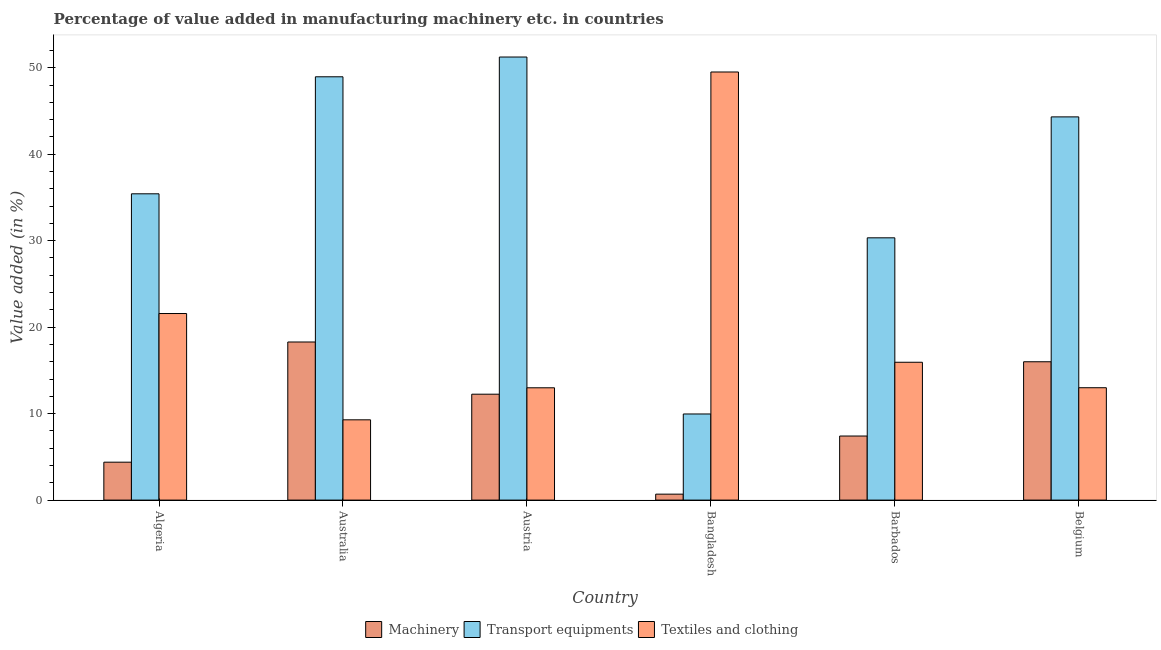Are the number of bars on each tick of the X-axis equal?
Ensure brevity in your answer.  Yes. How many bars are there on the 4th tick from the right?
Give a very brief answer. 3. In how many cases, is the number of bars for a given country not equal to the number of legend labels?
Your response must be concise. 0. What is the value added in manufacturing machinery in Belgium?
Ensure brevity in your answer.  16. Across all countries, what is the maximum value added in manufacturing textile and clothing?
Offer a terse response. 49.51. Across all countries, what is the minimum value added in manufacturing machinery?
Provide a succinct answer. 0.69. In which country was the value added in manufacturing textile and clothing minimum?
Keep it short and to the point. Australia. What is the total value added in manufacturing machinery in the graph?
Your response must be concise. 59.01. What is the difference between the value added in manufacturing transport equipments in Algeria and that in Barbados?
Give a very brief answer. 5.09. What is the difference between the value added in manufacturing textile and clothing in Belgium and the value added in manufacturing transport equipments in Austria?
Make the answer very short. -38.24. What is the average value added in manufacturing machinery per country?
Offer a terse response. 9.83. What is the difference between the value added in manufacturing textile and clothing and value added in manufacturing machinery in Algeria?
Offer a terse response. 17.19. What is the ratio of the value added in manufacturing transport equipments in Australia to that in Belgium?
Offer a very short reply. 1.1. What is the difference between the highest and the second highest value added in manufacturing transport equipments?
Ensure brevity in your answer.  2.28. What is the difference between the highest and the lowest value added in manufacturing machinery?
Offer a very short reply. 17.59. In how many countries, is the value added in manufacturing transport equipments greater than the average value added in manufacturing transport equipments taken over all countries?
Offer a very short reply. 3. What does the 1st bar from the left in Australia represents?
Your response must be concise. Machinery. What does the 1st bar from the right in Algeria represents?
Your answer should be compact. Textiles and clothing. How many bars are there?
Your answer should be very brief. 18. What is the difference between two consecutive major ticks on the Y-axis?
Offer a terse response. 10. Does the graph contain grids?
Offer a terse response. No. How many legend labels are there?
Offer a terse response. 3. How are the legend labels stacked?
Make the answer very short. Horizontal. What is the title of the graph?
Give a very brief answer. Percentage of value added in manufacturing machinery etc. in countries. Does "Central government" appear as one of the legend labels in the graph?
Keep it short and to the point. No. What is the label or title of the Y-axis?
Make the answer very short. Value added (in %). What is the Value added (in %) of Machinery in Algeria?
Your answer should be compact. 4.38. What is the Value added (in %) of Transport equipments in Algeria?
Make the answer very short. 35.42. What is the Value added (in %) in Textiles and clothing in Algeria?
Your answer should be compact. 21.57. What is the Value added (in %) of Machinery in Australia?
Your response must be concise. 18.28. What is the Value added (in %) in Transport equipments in Australia?
Make the answer very short. 48.95. What is the Value added (in %) in Textiles and clothing in Australia?
Your answer should be very brief. 9.28. What is the Value added (in %) in Machinery in Austria?
Offer a very short reply. 12.25. What is the Value added (in %) of Transport equipments in Austria?
Provide a short and direct response. 51.24. What is the Value added (in %) of Textiles and clothing in Austria?
Provide a succinct answer. 12.99. What is the Value added (in %) of Machinery in Bangladesh?
Offer a very short reply. 0.69. What is the Value added (in %) in Transport equipments in Bangladesh?
Offer a very short reply. 9.96. What is the Value added (in %) in Textiles and clothing in Bangladesh?
Give a very brief answer. 49.51. What is the Value added (in %) in Machinery in Barbados?
Give a very brief answer. 7.41. What is the Value added (in %) of Transport equipments in Barbados?
Your answer should be very brief. 30.33. What is the Value added (in %) in Textiles and clothing in Barbados?
Offer a terse response. 15.94. What is the Value added (in %) in Machinery in Belgium?
Your response must be concise. 16. What is the Value added (in %) in Transport equipments in Belgium?
Offer a terse response. 44.31. What is the Value added (in %) in Textiles and clothing in Belgium?
Your answer should be very brief. 12.99. Across all countries, what is the maximum Value added (in %) in Machinery?
Ensure brevity in your answer.  18.28. Across all countries, what is the maximum Value added (in %) of Transport equipments?
Keep it short and to the point. 51.24. Across all countries, what is the maximum Value added (in %) in Textiles and clothing?
Keep it short and to the point. 49.51. Across all countries, what is the minimum Value added (in %) in Machinery?
Provide a short and direct response. 0.69. Across all countries, what is the minimum Value added (in %) of Transport equipments?
Give a very brief answer. 9.96. Across all countries, what is the minimum Value added (in %) of Textiles and clothing?
Provide a succinct answer. 9.28. What is the total Value added (in %) of Machinery in the graph?
Provide a short and direct response. 59.01. What is the total Value added (in %) of Transport equipments in the graph?
Ensure brevity in your answer.  220.21. What is the total Value added (in %) in Textiles and clothing in the graph?
Your response must be concise. 122.28. What is the difference between the Value added (in %) in Machinery in Algeria and that in Australia?
Keep it short and to the point. -13.9. What is the difference between the Value added (in %) in Transport equipments in Algeria and that in Australia?
Your answer should be very brief. -13.53. What is the difference between the Value added (in %) of Textiles and clothing in Algeria and that in Australia?
Provide a short and direct response. 12.29. What is the difference between the Value added (in %) of Machinery in Algeria and that in Austria?
Offer a terse response. -7.86. What is the difference between the Value added (in %) in Transport equipments in Algeria and that in Austria?
Your answer should be compact. -15.82. What is the difference between the Value added (in %) of Textiles and clothing in Algeria and that in Austria?
Keep it short and to the point. 8.59. What is the difference between the Value added (in %) in Machinery in Algeria and that in Bangladesh?
Ensure brevity in your answer.  3.7. What is the difference between the Value added (in %) in Transport equipments in Algeria and that in Bangladesh?
Offer a very short reply. 25.46. What is the difference between the Value added (in %) of Textiles and clothing in Algeria and that in Bangladesh?
Make the answer very short. -27.93. What is the difference between the Value added (in %) of Machinery in Algeria and that in Barbados?
Your answer should be very brief. -3.03. What is the difference between the Value added (in %) of Transport equipments in Algeria and that in Barbados?
Provide a succinct answer. 5.09. What is the difference between the Value added (in %) of Textiles and clothing in Algeria and that in Barbados?
Give a very brief answer. 5.63. What is the difference between the Value added (in %) of Machinery in Algeria and that in Belgium?
Offer a very short reply. -11.61. What is the difference between the Value added (in %) in Transport equipments in Algeria and that in Belgium?
Your answer should be compact. -8.89. What is the difference between the Value added (in %) in Textiles and clothing in Algeria and that in Belgium?
Offer a terse response. 8.58. What is the difference between the Value added (in %) of Machinery in Australia and that in Austria?
Provide a short and direct response. 6.04. What is the difference between the Value added (in %) in Transport equipments in Australia and that in Austria?
Your answer should be very brief. -2.28. What is the difference between the Value added (in %) in Textiles and clothing in Australia and that in Austria?
Your answer should be very brief. -3.7. What is the difference between the Value added (in %) in Machinery in Australia and that in Bangladesh?
Offer a terse response. 17.59. What is the difference between the Value added (in %) in Transport equipments in Australia and that in Bangladesh?
Offer a terse response. 38.99. What is the difference between the Value added (in %) in Textiles and clothing in Australia and that in Bangladesh?
Keep it short and to the point. -40.22. What is the difference between the Value added (in %) of Machinery in Australia and that in Barbados?
Ensure brevity in your answer.  10.87. What is the difference between the Value added (in %) of Transport equipments in Australia and that in Barbados?
Offer a terse response. 18.62. What is the difference between the Value added (in %) of Textiles and clothing in Australia and that in Barbados?
Offer a terse response. -6.66. What is the difference between the Value added (in %) of Machinery in Australia and that in Belgium?
Your answer should be compact. 2.29. What is the difference between the Value added (in %) in Transport equipments in Australia and that in Belgium?
Provide a short and direct response. 4.64. What is the difference between the Value added (in %) in Textiles and clothing in Australia and that in Belgium?
Provide a succinct answer. -3.71. What is the difference between the Value added (in %) in Machinery in Austria and that in Bangladesh?
Your answer should be compact. 11.56. What is the difference between the Value added (in %) in Transport equipments in Austria and that in Bangladesh?
Keep it short and to the point. 41.28. What is the difference between the Value added (in %) of Textiles and clothing in Austria and that in Bangladesh?
Your response must be concise. -36.52. What is the difference between the Value added (in %) in Machinery in Austria and that in Barbados?
Offer a terse response. 4.84. What is the difference between the Value added (in %) of Transport equipments in Austria and that in Barbados?
Ensure brevity in your answer.  20.91. What is the difference between the Value added (in %) in Textiles and clothing in Austria and that in Barbados?
Your answer should be compact. -2.95. What is the difference between the Value added (in %) in Machinery in Austria and that in Belgium?
Your response must be concise. -3.75. What is the difference between the Value added (in %) in Transport equipments in Austria and that in Belgium?
Give a very brief answer. 6.92. What is the difference between the Value added (in %) of Textiles and clothing in Austria and that in Belgium?
Give a very brief answer. -0.01. What is the difference between the Value added (in %) in Machinery in Bangladesh and that in Barbados?
Your response must be concise. -6.72. What is the difference between the Value added (in %) of Transport equipments in Bangladesh and that in Barbados?
Your answer should be very brief. -20.37. What is the difference between the Value added (in %) of Textiles and clothing in Bangladesh and that in Barbados?
Your answer should be compact. 33.57. What is the difference between the Value added (in %) in Machinery in Bangladesh and that in Belgium?
Your answer should be very brief. -15.31. What is the difference between the Value added (in %) in Transport equipments in Bangladesh and that in Belgium?
Offer a very short reply. -34.35. What is the difference between the Value added (in %) of Textiles and clothing in Bangladesh and that in Belgium?
Keep it short and to the point. 36.51. What is the difference between the Value added (in %) of Machinery in Barbados and that in Belgium?
Ensure brevity in your answer.  -8.59. What is the difference between the Value added (in %) in Transport equipments in Barbados and that in Belgium?
Your response must be concise. -13.98. What is the difference between the Value added (in %) in Textiles and clothing in Barbados and that in Belgium?
Keep it short and to the point. 2.95. What is the difference between the Value added (in %) of Machinery in Algeria and the Value added (in %) of Transport equipments in Australia?
Provide a short and direct response. -44.57. What is the difference between the Value added (in %) in Machinery in Algeria and the Value added (in %) in Textiles and clothing in Australia?
Your answer should be very brief. -4.9. What is the difference between the Value added (in %) of Transport equipments in Algeria and the Value added (in %) of Textiles and clothing in Australia?
Offer a very short reply. 26.14. What is the difference between the Value added (in %) of Machinery in Algeria and the Value added (in %) of Transport equipments in Austria?
Your answer should be very brief. -46.85. What is the difference between the Value added (in %) in Machinery in Algeria and the Value added (in %) in Textiles and clothing in Austria?
Offer a very short reply. -8.6. What is the difference between the Value added (in %) of Transport equipments in Algeria and the Value added (in %) of Textiles and clothing in Austria?
Make the answer very short. 22.43. What is the difference between the Value added (in %) in Machinery in Algeria and the Value added (in %) in Transport equipments in Bangladesh?
Keep it short and to the point. -5.57. What is the difference between the Value added (in %) in Machinery in Algeria and the Value added (in %) in Textiles and clothing in Bangladesh?
Ensure brevity in your answer.  -45.12. What is the difference between the Value added (in %) of Transport equipments in Algeria and the Value added (in %) of Textiles and clothing in Bangladesh?
Offer a very short reply. -14.09. What is the difference between the Value added (in %) in Machinery in Algeria and the Value added (in %) in Transport equipments in Barbados?
Make the answer very short. -25.95. What is the difference between the Value added (in %) of Machinery in Algeria and the Value added (in %) of Textiles and clothing in Barbados?
Your answer should be very brief. -11.56. What is the difference between the Value added (in %) in Transport equipments in Algeria and the Value added (in %) in Textiles and clothing in Barbados?
Make the answer very short. 19.48. What is the difference between the Value added (in %) in Machinery in Algeria and the Value added (in %) in Transport equipments in Belgium?
Your answer should be very brief. -39.93. What is the difference between the Value added (in %) in Machinery in Algeria and the Value added (in %) in Textiles and clothing in Belgium?
Make the answer very short. -8.61. What is the difference between the Value added (in %) of Transport equipments in Algeria and the Value added (in %) of Textiles and clothing in Belgium?
Your response must be concise. 22.43. What is the difference between the Value added (in %) of Machinery in Australia and the Value added (in %) of Transport equipments in Austria?
Offer a very short reply. -32.95. What is the difference between the Value added (in %) in Machinery in Australia and the Value added (in %) in Textiles and clothing in Austria?
Your answer should be very brief. 5.3. What is the difference between the Value added (in %) of Transport equipments in Australia and the Value added (in %) of Textiles and clothing in Austria?
Offer a terse response. 35.96. What is the difference between the Value added (in %) of Machinery in Australia and the Value added (in %) of Transport equipments in Bangladesh?
Keep it short and to the point. 8.32. What is the difference between the Value added (in %) of Machinery in Australia and the Value added (in %) of Textiles and clothing in Bangladesh?
Offer a very short reply. -31.22. What is the difference between the Value added (in %) in Transport equipments in Australia and the Value added (in %) in Textiles and clothing in Bangladesh?
Your answer should be compact. -0.55. What is the difference between the Value added (in %) of Machinery in Australia and the Value added (in %) of Transport equipments in Barbados?
Your answer should be very brief. -12.05. What is the difference between the Value added (in %) in Machinery in Australia and the Value added (in %) in Textiles and clothing in Barbados?
Your answer should be very brief. 2.34. What is the difference between the Value added (in %) in Transport equipments in Australia and the Value added (in %) in Textiles and clothing in Barbados?
Offer a terse response. 33.01. What is the difference between the Value added (in %) of Machinery in Australia and the Value added (in %) of Transport equipments in Belgium?
Give a very brief answer. -26.03. What is the difference between the Value added (in %) of Machinery in Australia and the Value added (in %) of Textiles and clothing in Belgium?
Your answer should be very brief. 5.29. What is the difference between the Value added (in %) in Transport equipments in Australia and the Value added (in %) in Textiles and clothing in Belgium?
Make the answer very short. 35.96. What is the difference between the Value added (in %) of Machinery in Austria and the Value added (in %) of Transport equipments in Bangladesh?
Offer a terse response. 2.29. What is the difference between the Value added (in %) in Machinery in Austria and the Value added (in %) in Textiles and clothing in Bangladesh?
Your response must be concise. -37.26. What is the difference between the Value added (in %) in Transport equipments in Austria and the Value added (in %) in Textiles and clothing in Bangladesh?
Keep it short and to the point. 1.73. What is the difference between the Value added (in %) of Machinery in Austria and the Value added (in %) of Transport equipments in Barbados?
Make the answer very short. -18.08. What is the difference between the Value added (in %) of Machinery in Austria and the Value added (in %) of Textiles and clothing in Barbados?
Offer a terse response. -3.69. What is the difference between the Value added (in %) in Transport equipments in Austria and the Value added (in %) in Textiles and clothing in Barbados?
Your answer should be very brief. 35.29. What is the difference between the Value added (in %) in Machinery in Austria and the Value added (in %) in Transport equipments in Belgium?
Keep it short and to the point. -32.07. What is the difference between the Value added (in %) of Machinery in Austria and the Value added (in %) of Textiles and clothing in Belgium?
Your answer should be very brief. -0.75. What is the difference between the Value added (in %) in Transport equipments in Austria and the Value added (in %) in Textiles and clothing in Belgium?
Offer a terse response. 38.24. What is the difference between the Value added (in %) of Machinery in Bangladesh and the Value added (in %) of Transport equipments in Barbados?
Give a very brief answer. -29.64. What is the difference between the Value added (in %) of Machinery in Bangladesh and the Value added (in %) of Textiles and clothing in Barbados?
Ensure brevity in your answer.  -15.25. What is the difference between the Value added (in %) in Transport equipments in Bangladesh and the Value added (in %) in Textiles and clothing in Barbados?
Your answer should be very brief. -5.98. What is the difference between the Value added (in %) of Machinery in Bangladesh and the Value added (in %) of Transport equipments in Belgium?
Your response must be concise. -43.62. What is the difference between the Value added (in %) of Machinery in Bangladesh and the Value added (in %) of Textiles and clothing in Belgium?
Offer a very short reply. -12.3. What is the difference between the Value added (in %) of Transport equipments in Bangladesh and the Value added (in %) of Textiles and clothing in Belgium?
Keep it short and to the point. -3.03. What is the difference between the Value added (in %) of Machinery in Barbados and the Value added (in %) of Transport equipments in Belgium?
Offer a very short reply. -36.9. What is the difference between the Value added (in %) of Machinery in Barbados and the Value added (in %) of Textiles and clothing in Belgium?
Your response must be concise. -5.58. What is the difference between the Value added (in %) in Transport equipments in Barbados and the Value added (in %) in Textiles and clothing in Belgium?
Provide a succinct answer. 17.34. What is the average Value added (in %) of Machinery per country?
Make the answer very short. 9.83. What is the average Value added (in %) of Transport equipments per country?
Offer a very short reply. 36.7. What is the average Value added (in %) in Textiles and clothing per country?
Give a very brief answer. 20.38. What is the difference between the Value added (in %) in Machinery and Value added (in %) in Transport equipments in Algeria?
Provide a short and direct response. -31.04. What is the difference between the Value added (in %) of Machinery and Value added (in %) of Textiles and clothing in Algeria?
Your response must be concise. -17.19. What is the difference between the Value added (in %) in Transport equipments and Value added (in %) in Textiles and clothing in Algeria?
Offer a very short reply. 13.84. What is the difference between the Value added (in %) in Machinery and Value added (in %) in Transport equipments in Australia?
Your answer should be compact. -30.67. What is the difference between the Value added (in %) of Machinery and Value added (in %) of Textiles and clothing in Australia?
Provide a short and direct response. 9. What is the difference between the Value added (in %) of Transport equipments and Value added (in %) of Textiles and clothing in Australia?
Your response must be concise. 39.67. What is the difference between the Value added (in %) of Machinery and Value added (in %) of Transport equipments in Austria?
Provide a short and direct response. -38.99. What is the difference between the Value added (in %) in Machinery and Value added (in %) in Textiles and clothing in Austria?
Offer a terse response. -0.74. What is the difference between the Value added (in %) of Transport equipments and Value added (in %) of Textiles and clothing in Austria?
Provide a succinct answer. 38.25. What is the difference between the Value added (in %) of Machinery and Value added (in %) of Transport equipments in Bangladesh?
Provide a succinct answer. -9.27. What is the difference between the Value added (in %) of Machinery and Value added (in %) of Textiles and clothing in Bangladesh?
Offer a terse response. -48.82. What is the difference between the Value added (in %) in Transport equipments and Value added (in %) in Textiles and clothing in Bangladesh?
Keep it short and to the point. -39.55. What is the difference between the Value added (in %) in Machinery and Value added (in %) in Transport equipments in Barbados?
Give a very brief answer. -22.92. What is the difference between the Value added (in %) of Machinery and Value added (in %) of Textiles and clothing in Barbados?
Offer a terse response. -8.53. What is the difference between the Value added (in %) in Transport equipments and Value added (in %) in Textiles and clothing in Barbados?
Keep it short and to the point. 14.39. What is the difference between the Value added (in %) of Machinery and Value added (in %) of Transport equipments in Belgium?
Your answer should be compact. -28.32. What is the difference between the Value added (in %) of Machinery and Value added (in %) of Textiles and clothing in Belgium?
Make the answer very short. 3. What is the difference between the Value added (in %) of Transport equipments and Value added (in %) of Textiles and clothing in Belgium?
Provide a short and direct response. 31.32. What is the ratio of the Value added (in %) of Machinery in Algeria to that in Australia?
Provide a succinct answer. 0.24. What is the ratio of the Value added (in %) of Transport equipments in Algeria to that in Australia?
Your answer should be compact. 0.72. What is the ratio of the Value added (in %) of Textiles and clothing in Algeria to that in Australia?
Your answer should be very brief. 2.32. What is the ratio of the Value added (in %) in Machinery in Algeria to that in Austria?
Ensure brevity in your answer.  0.36. What is the ratio of the Value added (in %) of Transport equipments in Algeria to that in Austria?
Ensure brevity in your answer.  0.69. What is the ratio of the Value added (in %) of Textiles and clothing in Algeria to that in Austria?
Your response must be concise. 1.66. What is the ratio of the Value added (in %) of Machinery in Algeria to that in Bangladesh?
Make the answer very short. 6.36. What is the ratio of the Value added (in %) in Transport equipments in Algeria to that in Bangladesh?
Provide a succinct answer. 3.56. What is the ratio of the Value added (in %) of Textiles and clothing in Algeria to that in Bangladesh?
Offer a very short reply. 0.44. What is the ratio of the Value added (in %) of Machinery in Algeria to that in Barbados?
Your answer should be compact. 0.59. What is the ratio of the Value added (in %) in Transport equipments in Algeria to that in Barbados?
Give a very brief answer. 1.17. What is the ratio of the Value added (in %) of Textiles and clothing in Algeria to that in Barbados?
Offer a very short reply. 1.35. What is the ratio of the Value added (in %) in Machinery in Algeria to that in Belgium?
Ensure brevity in your answer.  0.27. What is the ratio of the Value added (in %) of Transport equipments in Algeria to that in Belgium?
Your answer should be very brief. 0.8. What is the ratio of the Value added (in %) of Textiles and clothing in Algeria to that in Belgium?
Offer a very short reply. 1.66. What is the ratio of the Value added (in %) of Machinery in Australia to that in Austria?
Make the answer very short. 1.49. What is the ratio of the Value added (in %) in Transport equipments in Australia to that in Austria?
Keep it short and to the point. 0.96. What is the ratio of the Value added (in %) in Textiles and clothing in Australia to that in Austria?
Provide a short and direct response. 0.71. What is the ratio of the Value added (in %) in Machinery in Australia to that in Bangladesh?
Keep it short and to the point. 26.53. What is the ratio of the Value added (in %) of Transport equipments in Australia to that in Bangladesh?
Offer a very short reply. 4.92. What is the ratio of the Value added (in %) in Textiles and clothing in Australia to that in Bangladesh?
Provide a short and direct response. 0.19. What is the ratio of the Value added (in %) in Machinery in Australia to that in Barbados?
Keep it short and to the point. 2.47. What is the ratio of the Value added (in %) in Transport equipments in Australia to that in Barbados?
Your response must be concise. 1.61. What is the ratio of the Value added (in %) in Textiles and clothing in Australia to that in Barbados?
Offer a very short reply. 0.58. What is the ratio of the Value added (in %) of Machinery in Australia to that in Belgium?
Make the answer very short. 1.14. What is the ratio of the Value added (in %) of Transport equipments in Australia to that in Belgium?
Your response must be concise. 1.1. What is the ratio of the Value added (in %) in Textiles and clothing in Australia to that in Belgium?
Give a very brief answer. 0.71. What is the ratio of the Value added (in %) in Machinery in Austria to that in Bangladesh?
Provide a succinct answer. 17.77. What is the ratio of the Value added (in %) of Transport equipments in Austria to that in Bangladesh?
Provide a short and direct response. 5.14. What is the ratio of the Value added (in %) in Textiles and clothing in Austria to that in Bangladesh?
Provide a short and direct response. 0.26. What is the ratio of the Value added (in %) in Machinery in Austria to that in Barbados?
Provide a succinct answer. 1.65. What is the ratio of the Value added (in %) of Transport equipments in Austria to that in Barbados?
Ensure brevity in your answer.  1.69. What is the ratio of the Value added (in %) in Textiles and clothing in Austria to that in Barbados?
Provide a succinct answer. 0.81. What is the ratio of the Value added (in %) of Machinery in Austria to that in Belgium?
Ensure brevity in your answer.  0.77. What is the ratio of the Value added (in %) in Transport equipments in Austria to that in Belgium?
Offer a terse response. 1.16. What is the ratio of the Value added (in %) in Textiles and clothing in Austria to that in Belgium?
Ensure brevity in your answer.  1. What is the ratio of the Value added (in %) of Machinery in Bangladesh to that in Barbados?
Your answer should be compact. 0.09. What is the ratio of the Value added (in %) in Transport equipments in Bangladesh to that in Barbados?
Offer a very short reply. 0.33. What is the ratio of the Value added (in %) in Textiles and clothing in Bangladesh to that in Barbados?
Provide a succinct answer. 3.11. What is the ratio of the Value added (in %) of Machinery in Bangladesh to that in Belgium?
Your answer should be compact. 0.04. What is the ratio of the Value added (in %) in Transport equipments in Bangladesh to that in Belgium?
Provide a succinct answer. 0.22. What is the ratio of the Value added (in %) in Textiles and clothing in Bangladesh to that in Belgium?
Your answer should be compact. 3.81. What is the ratio of the Value added (in %) of Machinery in Barbados to that in Belgium?
Offer a terse response. 0.46. What is the ratio of the Value added (in %) of Transport equipments in Barbados to that in Belgium?
Your answer should be very brief. 0.68. What is the ratio of the Value added (in %) in Textiles and clothing in Barbados to that in Belgium?
Give a very brief answer. 1.23. What is the difference between the highest and the second highest Value added (in %) in Machinery?
Ensure brevity in your answer.  2.29. What is the difference between the highest and the second highest Value added (in %) in Transport equipments?
Provide a succinct answer. 2.28. What is the difference between the highest and the second highest Value added (in %) in Textiles and clothing?
Provide a succinct answer. 27.93. What is the difference between the highest and the lowest Value added (in %) of Machinery?
Your answer should be very brief. 17.59. What is the difference between the highest and the lowest Value added (in %) in Transport equipments?
Provide a succinct answer. 41.28. What is the difference between the highest and the lowest Value added (in %) of Textiles and clothing?
Keep it short and to the point. 40.22. 